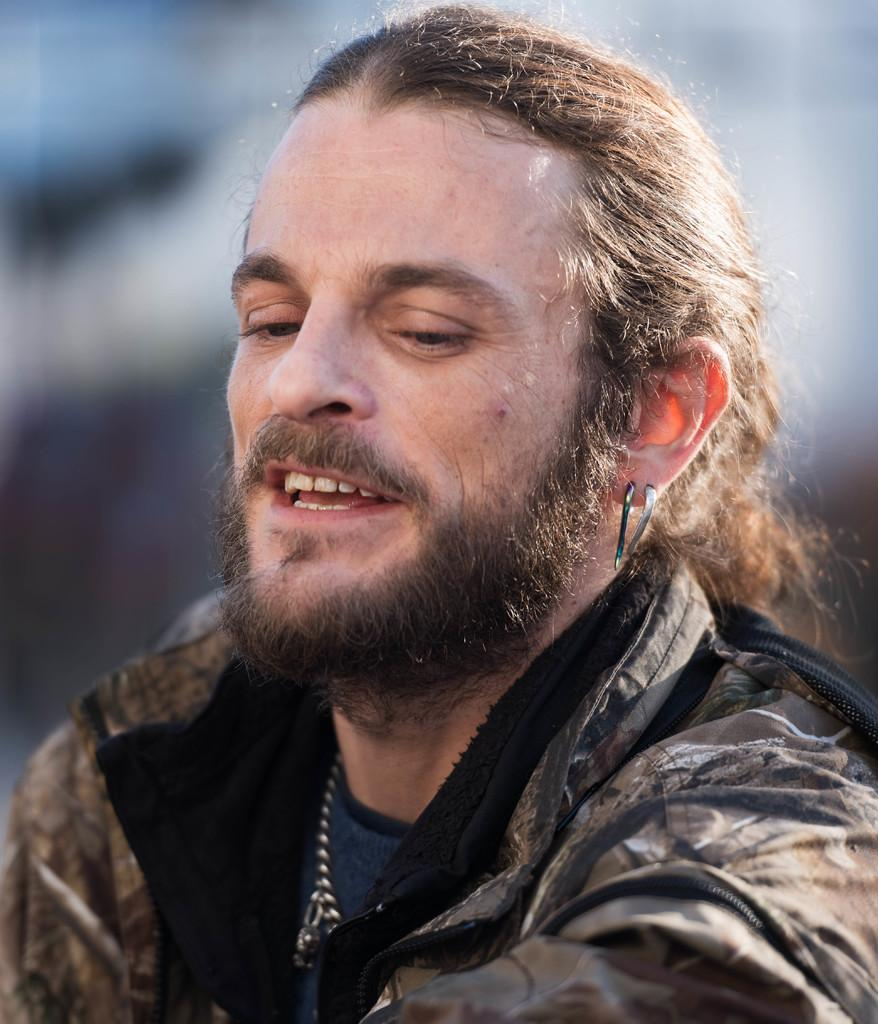What is the main subject of the image? There is a person in the image. What is the person's expression in the image? The person is smiling in the image. Can you describe the background of the image? The background of the image is blurry. What type of humor is the person discussing in the image? There is no indication in the image that the person is discussing humor or any specific topic. 